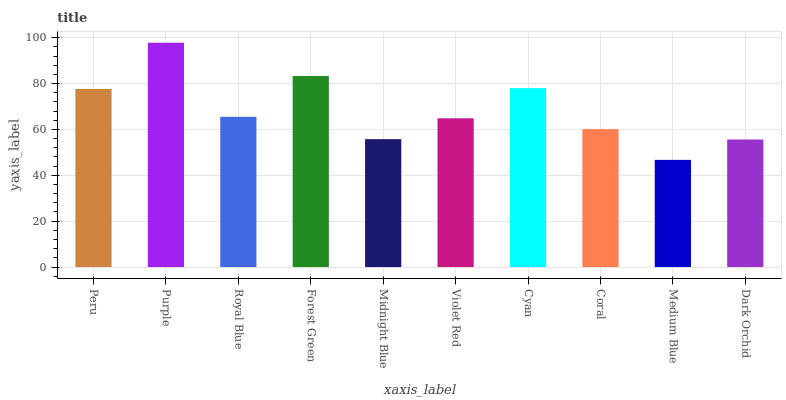Is Medium Blue the minimum?
Answer yes or no. Yes. Is Purple the maximum?
Answer yes or no. Yes. Is Royal Blue the minimum?
Answer yes or no. No. Is Royal Blue the maximum?
Answer yes or no. No. Is Purple greater than Royal Blue?
Answer yes or no. Yes. Is Royal Blue less than Purple?
Answer yes or no. Yes. Is Royal Blue greater than Purple?
Answer yes or no. No. Is Purple less than Royal Blue?
Answer yes or no. No. Is Royal Blue the high median?
Answer yes or no. Yes. Is Violet Red the low median?
Answer yes or no. Yes. Is Medium Blue the high median?
Answer yes or no. No. Is Cyan the low median?
Answer yes or no. No. 